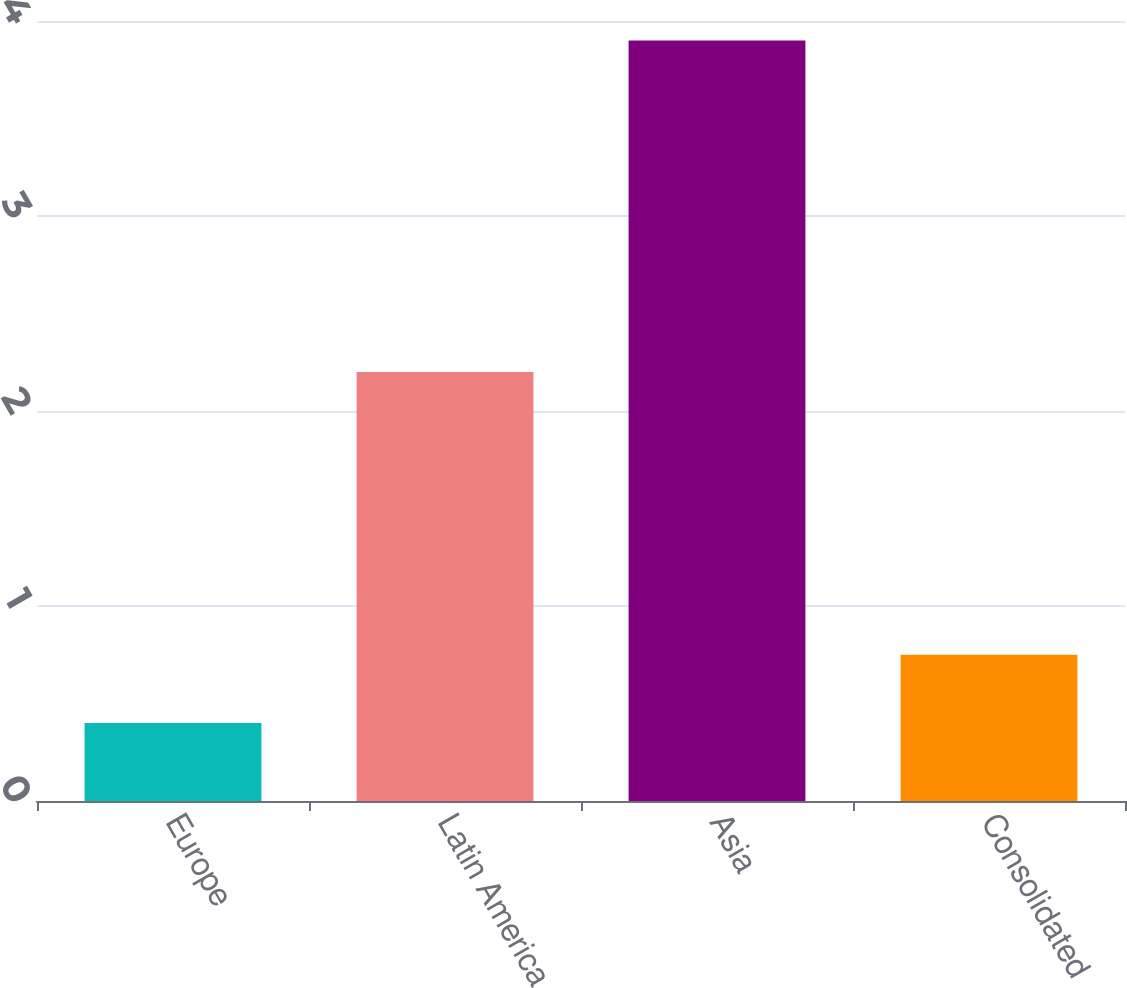Convert chart. <chart><loc_0><loc_0><loc_500><loc_500><bar_chart><fcel>Europe<fcel>Latin America<fcel>Asia<fcel>Consolidated<nl><fcel>0.4<fcel>2.2<fcel>3.9<fcel>0.75<nl></chart> 